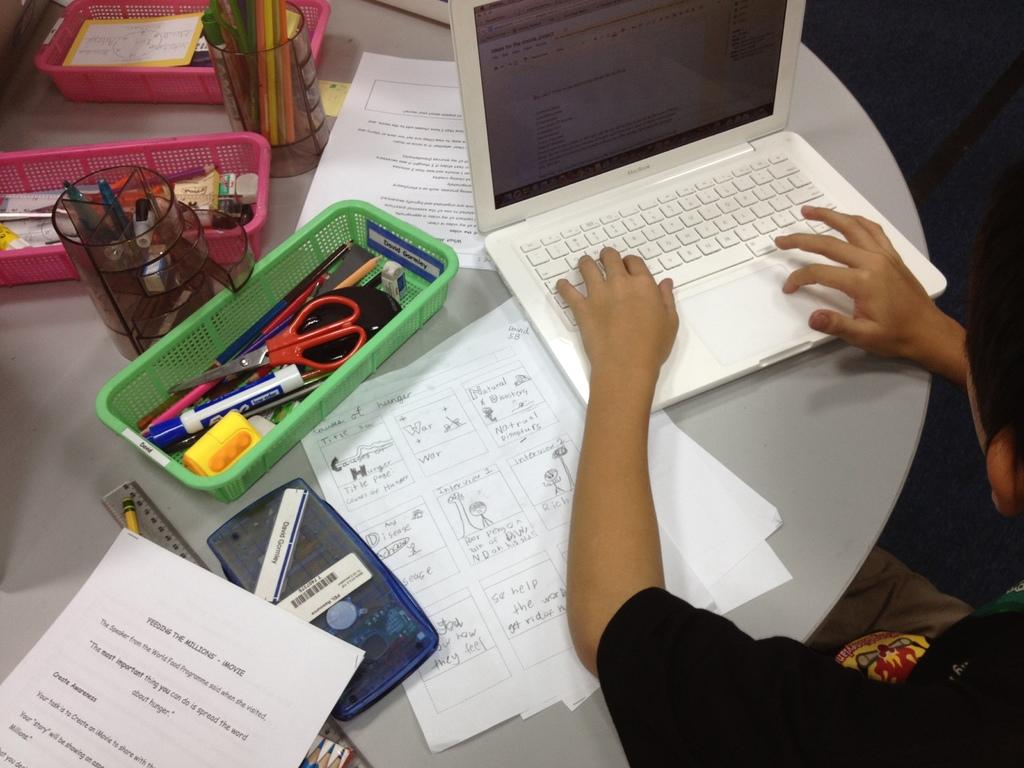<image>
Relay a brief, clear account of the picture shown. A child at a table working on schoolwork and a assignment on the causes of hunger. 